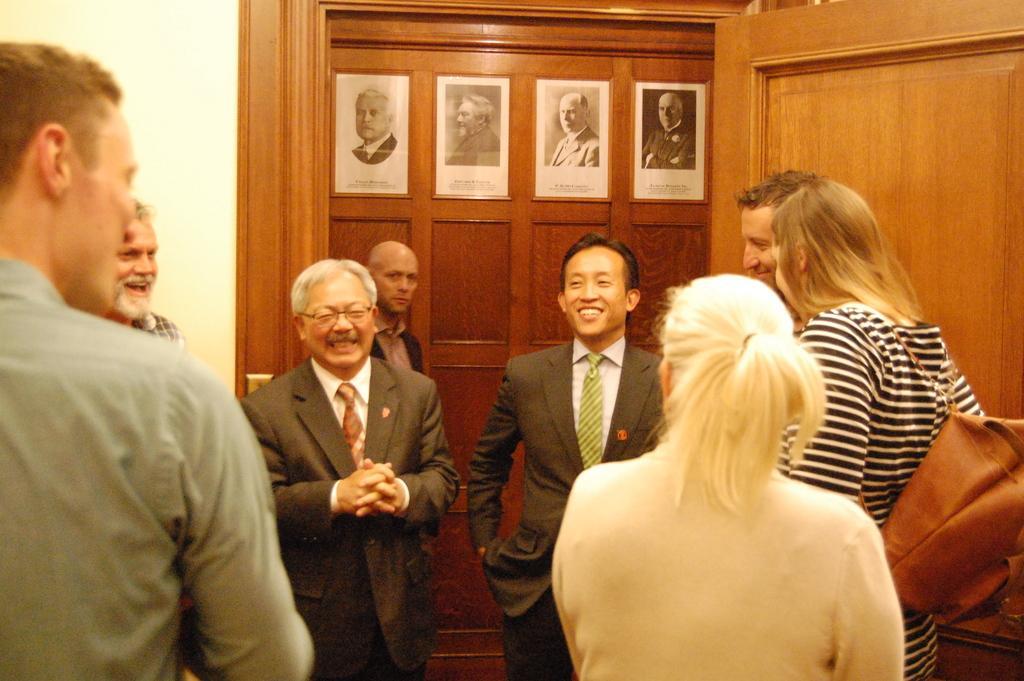Describe this image in one or two sentences. In this image, we can see persons wearing clothes. There are photo frames at the top of the image. There is a door in the top right of the image. There is a person on the right side of the image wearing a bag. 